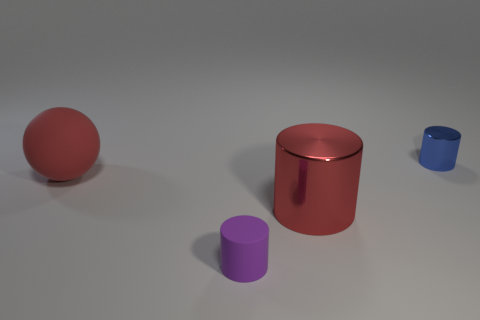Subtract all large shiny cylinders. How many cylinders are left? 2 Subtract all cylinders. How many objects are left? 1 Add 4 big green matte spheres. How many objects exist? 8 Subtract all blue cylinders. How many cylinders are left? 2 Subtract 1 balls. How many balls are left? 0 Subtract 1 red spheres. How many objects are left? 3 Subtract all gray cylinders. Subtract all brown blocks. How many cylinders are left? 3 Subtract all yellow balls. How many cyan cylinders are left? 0 Subtract all large spheres. Subtract all cylinders. How many objects are left? 0 Add 1 big red spheres. How many big red spheres are left? 2 